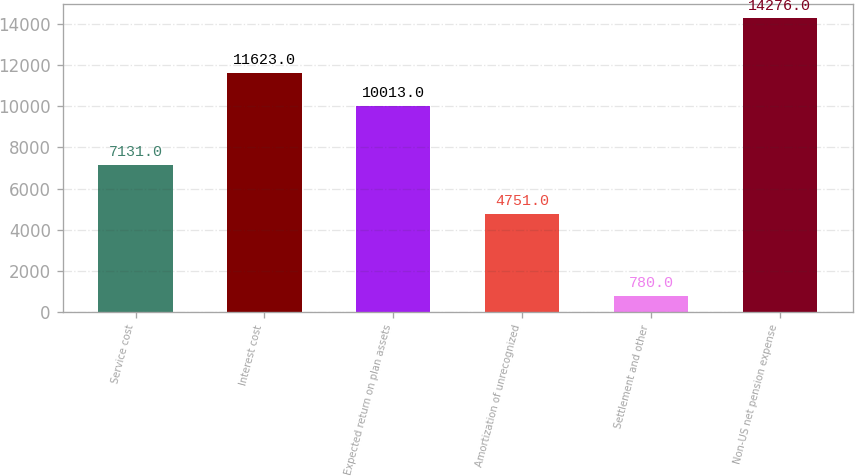Convert chart. <chart><loc_0><loc_0><loc_500><loc_500><bar_chart><fcel>Service cost<fcel>Interest cost<fcel>Expected return on plan assets<fcel>Amortization of unrecognized<fcel>Settlement and other<fcel>Non-US net pension expense<nl><fcel>7131<fcel>11623<fcel>10013<fcel>4751<fcel>780<fcel>14276<nl></chart> 